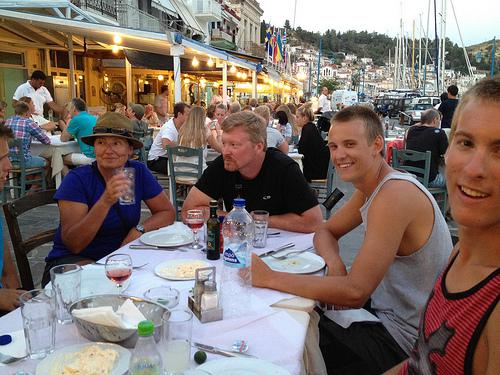Question: who is wearing a hat?
Choices:
A. The man sitting down.
B. The woman on the left.
C. The little girl in pink.
D. The boy with the ball.
Answer with the letter. Answer: B Question: how many people are sitting at the front table?
Choices:
A. 0.
B. 2.
C. 6.
D. 4.
Answer with the letter. Answer: D Question: what are these people doing?
Choices:
A. Playing a game.
B. Singing a song.
C. Playing the violin.
D. Eating and drinking.
Answer with the letter. Answer: D Question: where are these people?
Choices:
A. At a movie.
B. At a restaurant.
C. At the park.
D. At the farmers market.
Answer with the letter. Answer: B Question: what can you see in the background?
Choices:
A. Jet Skis.
B. Boats.
C. Cars.
D. Trains.
Answer with the letter. Answer: B Question: how many people of the four in the front have a mustache?
Choices:
A. 2.
B. 0.
C. 4.
D. 1.
Answer with the letter. Answer: D 